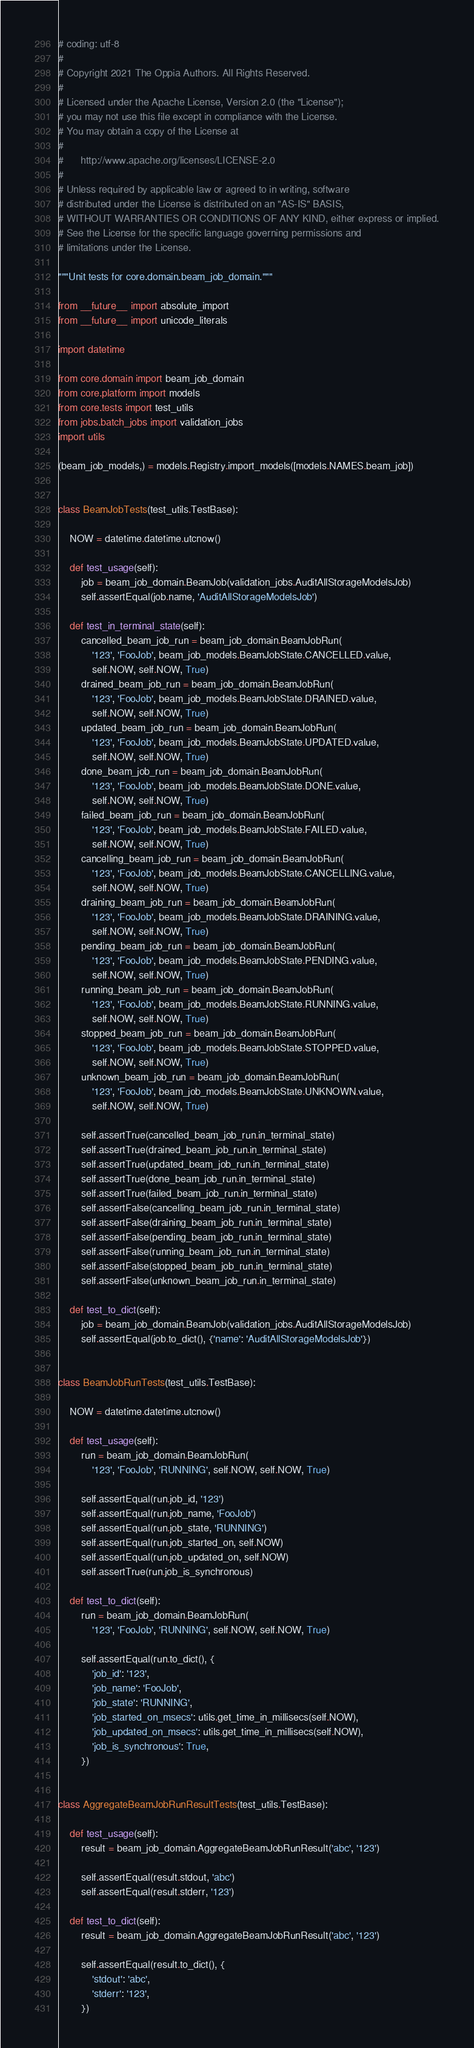Convert code to text. <code><loc_0><loc_0><loc_500><loc_500><_Python_># coding: utf-8
#
# Copyright 2021 The Oppia Authors. All Rights Reserved.
#
# Licensed under the Apache License, Version 2.0 (the "License");
# you may not use this file except in compliance with the License.
# You may obtain a copy of the License at
#
#      http://www.apache.org/licenses/LICENSE-2.0
#
# Unless required by applicable law or agreed to in writing, software
# distributed under the License is distributed on an "AS-IS" BASIS,
# WITHOUT WARRANTIES OR CONDITIONS OF ANY KIND, either express or implied.
# See the License for the specific language governing permissions and
# limitations under the License.

"""Unit tests for core.domain.beam_job_domain."""

from __future__ import absolute_import
from __future__ import unicode_literals

import datetime

from core.domain import beam_job_domain
from core.platform import models
from core.tests import test_utils
from jobs.batch_jobs import validation_jobs
import utils

(beam_job_models,) = models.Registry.import_models([models.NAMES.beam_job])


class BeamJobTests(test_utils.TestBase):

    NOW = datetime.datetime.utcnow()

    def test_usage(self):
        job = beam_job_domain.BeamJob(validation_jobs.AuditAllStorageModelsJob)
        self.assertEqual(job.name, 'AuditAllStorageModelsJob')

    def test_in_terminal_state(self):
        cancelled_beam_job_run = beam_job_domain.BeamJobRun(
            '123', 'FooJob', beam_job_models.BeamJobState.CANCELLED.value,
            self.NOW, self.NOW, True)
        drained_beam_job_run = beam_job_domain.BeamJobRun(
            '123', 'FooJob', beam_job_models.BeamJobState.DRAINED.value,
            self.NOW, self.NOW, True)
        updated_beam_job_run = beam_job_domain.BeamJobRun(
            '123', 'FooJob', beam_job_models.BeamJobState.UPDATED.value,
            self.NOW, self.NOW, True)
        done_beam_job_run = beam_job_domain.BeamJobRun(
            '123', 'FooJob', beam_job_models.BeamJobState.DONE.value,
            self.NOW, self.NOW, True)
        failed_beam_job_run = beam_job_domain.BeamJobRun(
            '123', 'FooJob', beam_job_models.BeamJobState.FAILED.value,
            self.NOW, self.NOW, True)
        cancelling_beam_job_run = beam_job_domain.BeamJobRun(
            '123', 'FooJob', beam_job_models.BeamJobState.CANCELLING.value,
            self.NOW, self.NOW, True)
        draining_beam_job_run = beam_job_domain.BeamJobRun(
            '123', 'FooJob', beam_job_models.BeamJobState.DRAINING.value,
            self.NOW, self.NOW, True)
        pending_beam_job_run = beam_job_domain.BeamJobRun(
            '123', 'FooJob', beam_job_models.BeamJobState.PENDING.value,
            self.NOW, self.NOW, True)
        running_beam_job_run = beam_job_domain.BeamJobRun(
            '123', 'FooJob', beam_job_models.BeamJobState.RUNNING.value,
            self.NOW, self.NOW, True)
        stopped_beam_job_run = beam_job_domain.BeamJobRun(
            '123', 'FooJob', beam_job_models.BeamJobState.STOPPED.value,
            self.NOW, self.NOW, True)
        unknown_beam_job_run = beam_job_domain.BeamJobRun(
            '123', 'FooJob', beam_job_models.BeamJobState.UNKNOWN.value,
            self.NOW, self.NOW, True)

        self.assertTrue(cancelled_beam_job_run.in_terminal_state)
        self.assertTrue(drained_beam_job_run.in_terminal_state)
        self.assertTrue(updated_beam_job_run.in_terminal_state)
        self.assertTrue(done_beam_job_run.in_terminal_state)
        self.assertTrue(failed_beam_job_run.in_terminal_state)
        self.assertFalse(cancelling_beam_job_run.in_terminal_state)
        self.assertFalse(draining_beam_job_run.in_terminal_state)
        self.assertFalse(pending_beam_job_run.in_terminal_state)
        self.assertFalse(running_beam_job_run.in_terminal_state)
        self.assertFalse(stopped_beam_job_run.in_terminal_state)
        self.assertFalse(unknown_beam_job_run.in_terminal_state)

    def test_to_dict(self):
        job = beam_job_domain.BeamJob(validation_jobs.AuditAllStorageModelsJob)
        self.assertEqual(job.to_dict(), {'name': 'AuditAllStorageModelsJob'})


class BeamJobRunTests(test_utils.TestBase):

    NOW = datetime.datetime.utcnow()

    def test_usage(self):
        run = beam_job_domain.BeamJobRun(
            '123', 'FooJob', 'RUNNING', self.NOW, self.NOW, True)

        self.assertEqual(run.job_id, '123')
        self.assertEqual(run.job_name, 'FooJob')
        self.assertEqual(run.job_state, 'RUNNING')
        self.assertEqual(run.job_started_on, self.NOW)
        self.assertEqual(run.job_updated_on, self.NOW)
        self.assertTrue(run.job_is_synchronous)

    def test_to_dict(self):
        run = beam_job_domain.BeamJobRun(
            '123', 'FooJob', 'RUNNING', self.NOW, self.NOW, True)

        self.assertEqual(run.to_dict(), {
            'job_id': '123',
            'job_name': 'FooJob',
            'job_state': 'RUNNING',
            'job_started_on_msecs': utils.get_time_in_millisecs(self.NOW),
            'job_updated_on_msecs': utils.get_time_in_millisecs(self.NOW),
            'job_is_synchronous': True,
        })


class AggregateBeamJobRunResultTests(test_utils.TestBase):

    def test_usage(self):
        result = beam_job_domain.AggregateBeamJobRunResult('abc', '123')

        self.assertEqual(result.stdout, 'abc')
        self.assertEqual(result.stderr, '123')

    def test_to_dict(self):
        result = beam_job_domain.AggregateBeamJobRunResult('abc', '123')

        self.assertEqual(result.to_dict(), {
            'stdout': 'abc',
            'stderr': '123',
        })
</code> 